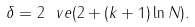<formula> <loc_0><loc_0><loc_500><loc_500>\delta = 2 \ v e ( 2 + ( k + 1 ) \ln N ) .</formula> 